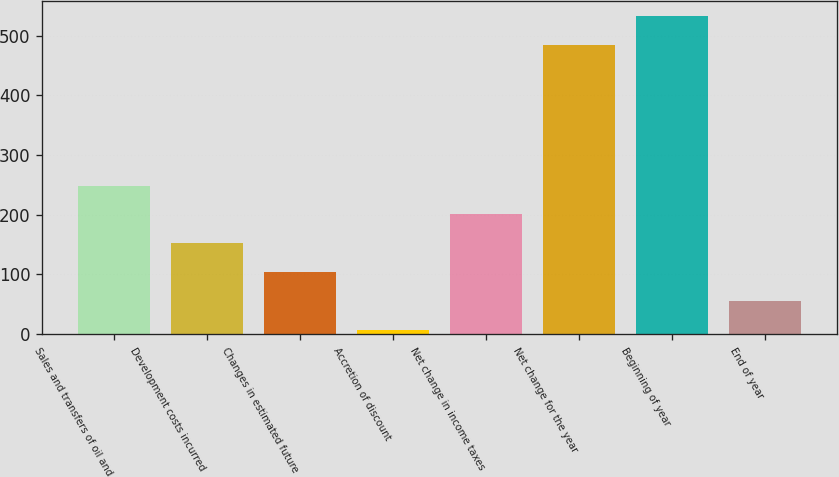Convert chart. <chart><loc_0><loc_0><loc_500><loc_500><bar_chart><fcel>Sales and transfers of oil and<fcel>Development costs incurred<fcel>Changes in estimated future<fcel>Accretion of discount<fcel>Net change in income taxes<fcel>Net change for the year<fcel>Beginning of year<fcel>End of year<nl><fcel>249<fcel>151.8<fcel>103.2<fcel>6<fcel>200.4<fcel>484<fcel>532.6<fcel>54.6<nl></chart> 